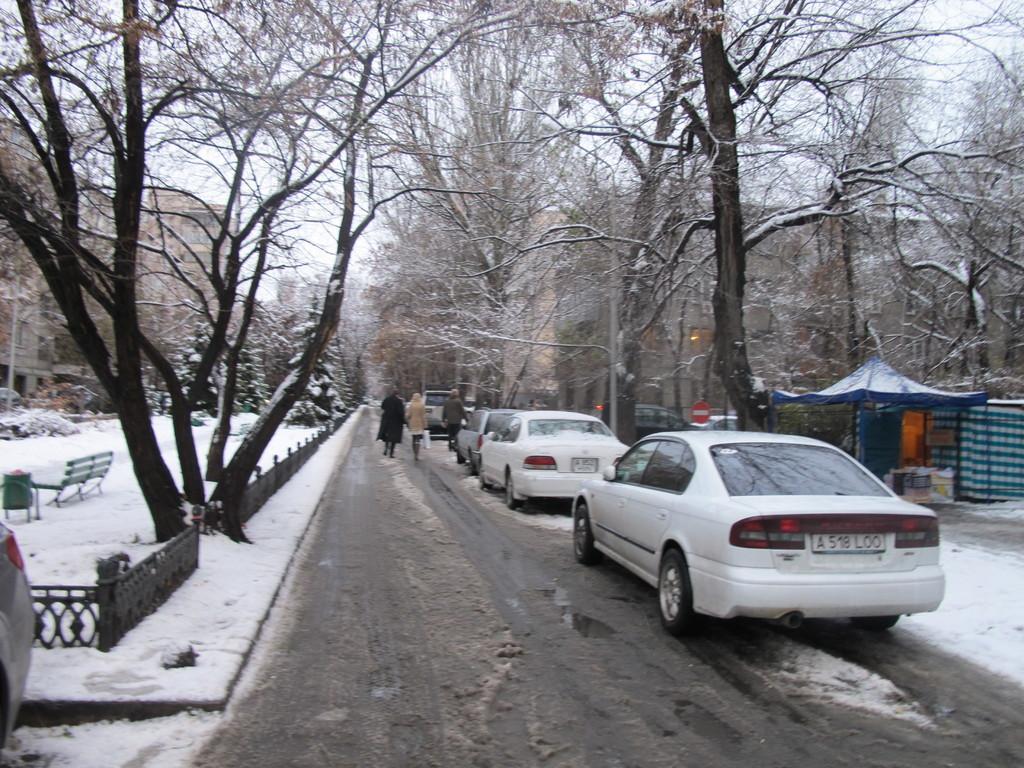Describe this image in one or two sentences. In this image I can see the road, few vehicles on the road, few persons standing, some snow, few trees, a tent, a bench and in the background I can see few buildings and the sky. 